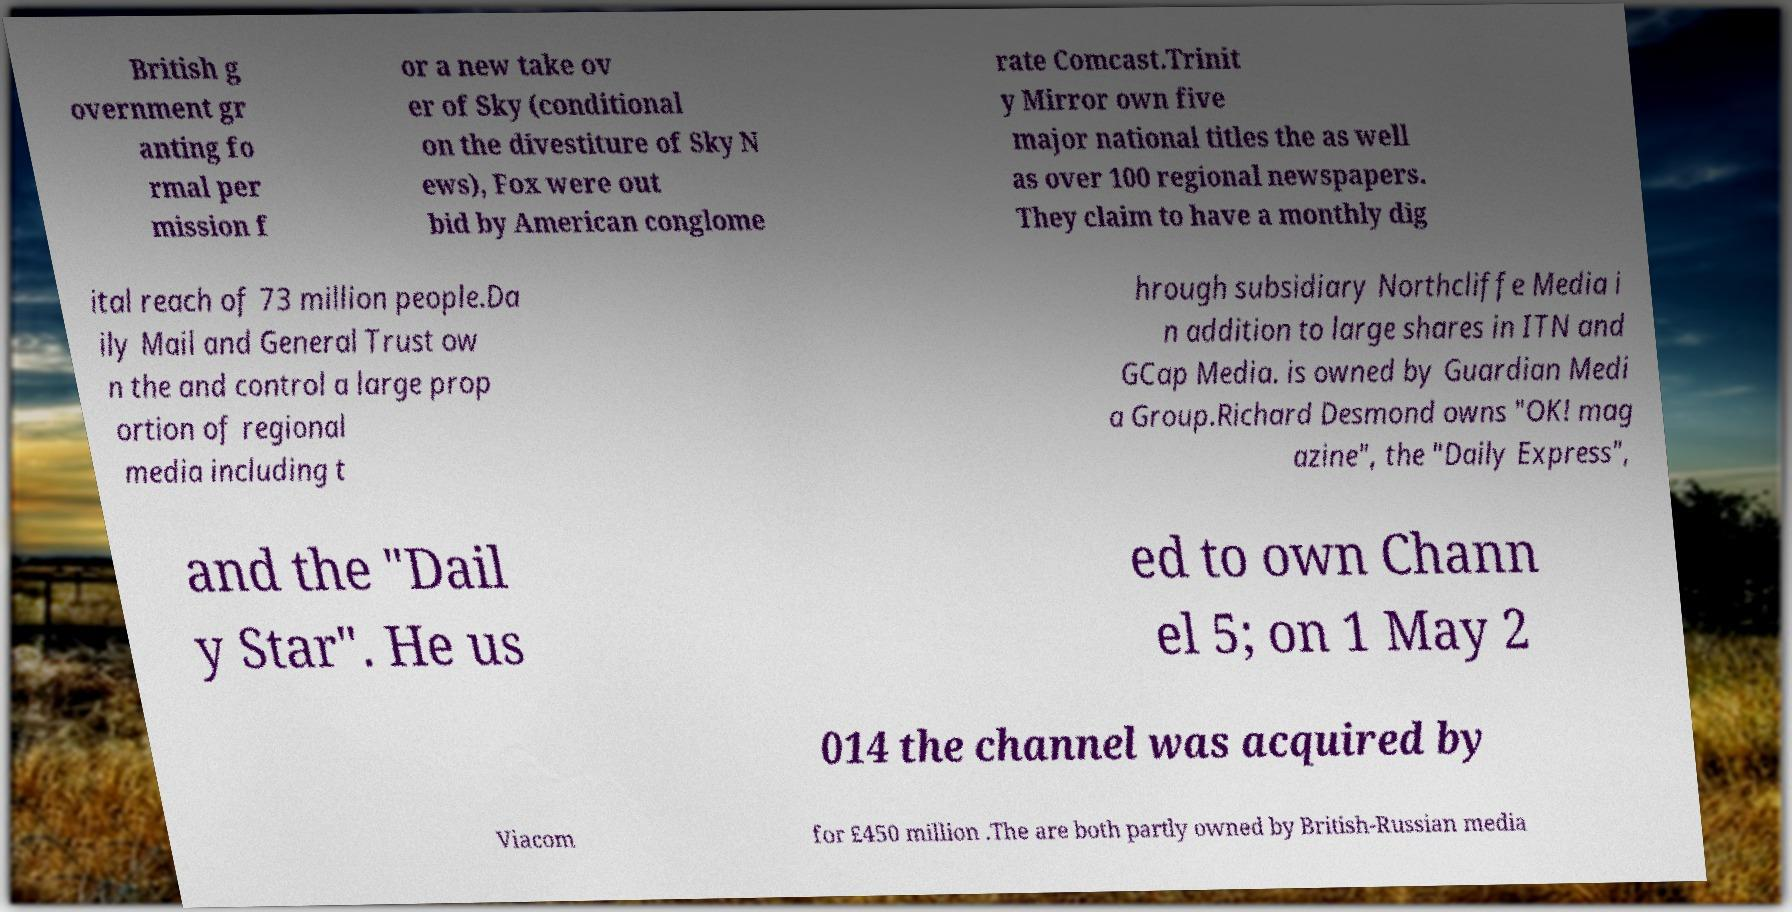What messages or text are displayed in this image? I need them in a readable, typed format. British g overnment gr anting fo rmal per mission f or a new take ov er of Sky (conditional on the divestiture of Sky N ews), Fox were out bid by American conglome rate Comcast.Trinit y Mirror own five major national titles the as well as over 100 regional newspapers. They claim to have a monthly dig ital reach of 73 million people.Da ily Mail and General Trust ow n the and control a large prop ortion of regional media including t hrough subsidiary Northcliffe Media i n addition to large shares in ITN and GCap Media. is owned by Guardian Medi a Group.Richard Desmond owns "OK! mag azine", the "Daily Express", and the "Dail y Star". He us ed to own Chann el 5; on 1 May 2 014 the channel was acquired by Viacom for £450 million .The are both partly owned by British-Russian media 